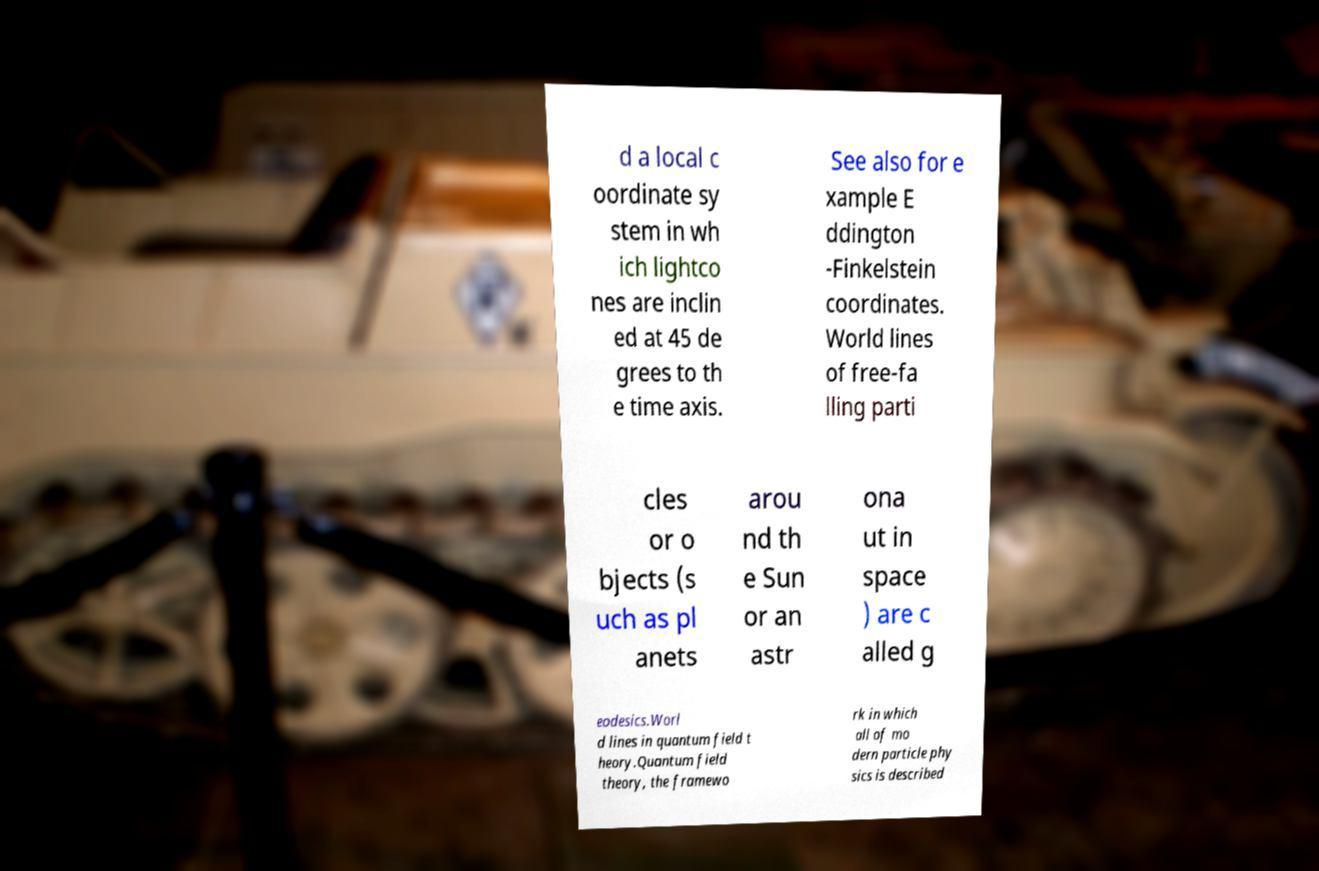Could you extract and type out the text from this image? d a local c oordinate sy stem in wh ich lightco nes are inclin ed at 45 de grees to th e time axis. See also for e xample E ddington -Finkelstein coordinates. World lines of free-fa lling parti cles or o bjects (s uch as pl anets arou nd th e Sun or an astr ona ut in space ) are c alled g eodesics.Worl d lines in quantum field t heory.Quantum field theory, the framewo rk in which all of mo dern particle phy sics is described 